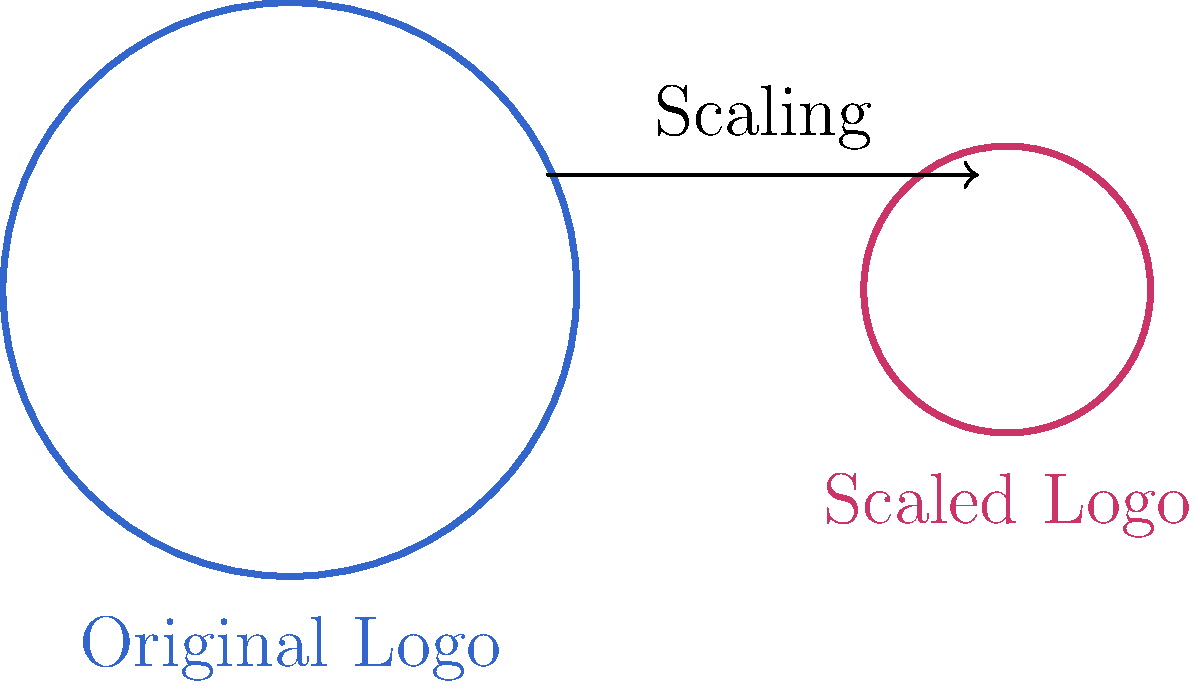A circular logo for a social media platform has a perimeter of 62.8 inches. For a different platform, the logo needs to be scaled down so that its new perimeter is 70% of the original. What is the difference in diameter between the original and scaled logos? Let's approach this step-by-step:

1) First, let's recall the formula for the perimeter (circumference) of a circle:
   $$ P = 2\pi r $$
   where $P$ is the perimeter and $r$ is the radius.

2) We're given that the original perimeter is 62.8 inches. Let's call the original radius $r_1$:
   $$ 62.8 = 2\pi r_1 $$

3) Solve for $r_1$:
   $$ r_1 = \frac{62.8}{2\pi} = 10 \text{ inches} $$

4) The diameter is twice the radius, so the original diameter $d_1 = 20$ inches.

5) Now, the new perimeter is 70% of the original:
   $$ P_2 = 0.7 \times 62.8 = 43.96 \text{ inches} $$

6) Using the same formula for the new radius $r_2$:
   $$ 43.96 = 2\pi r_2 $$
   $$ r_2 = \frac{43.96}{2\pi} = 7 \text{ inches} $$

7) The new diameter $d_2 = 14$ inches.

8) The difference in diameters:
   $$ d_1 - d_2 = 20 - 14 = 6 \text{ inches} $$
Answer: 6 inches 